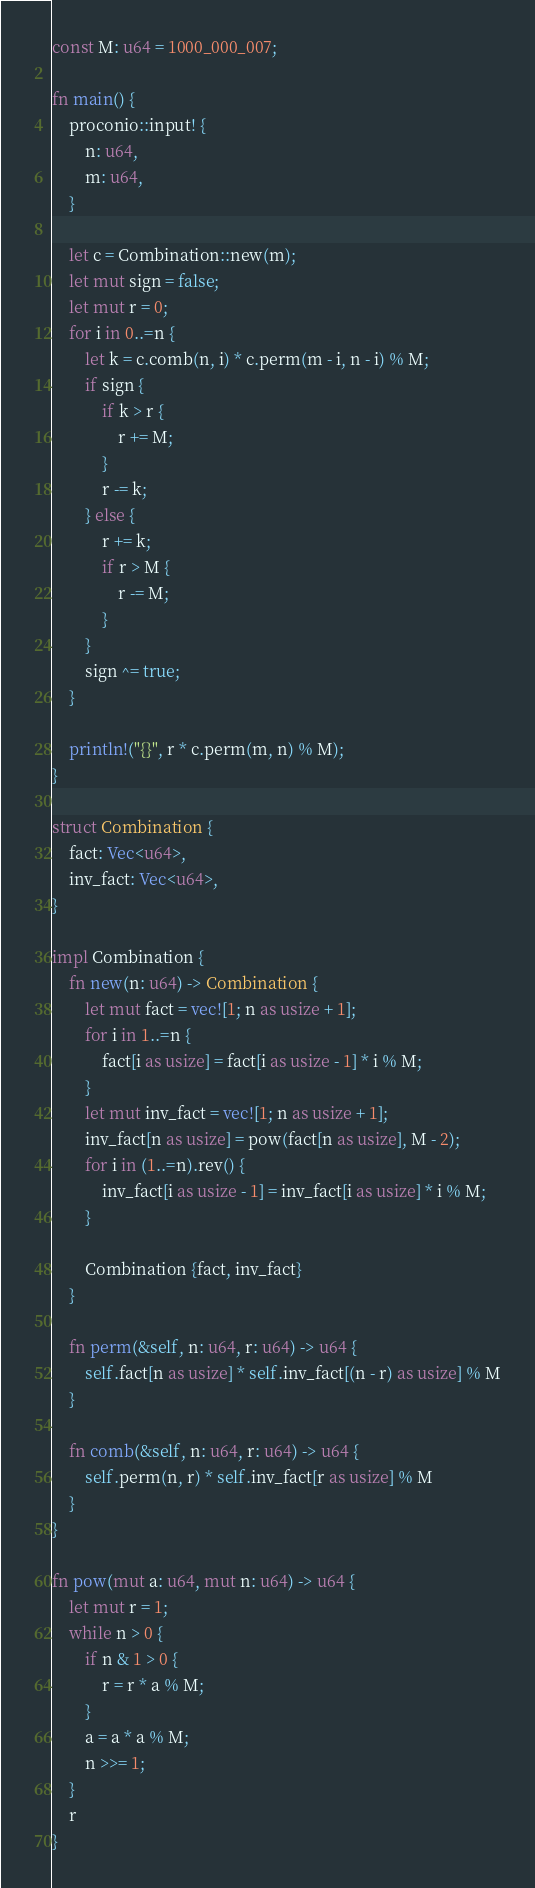<code> <loc_0><loc_0><loc_500><loc_500><_Rust_>const M: u64 = 1000_000_007;

fn main() {
    proconio::input! {
        n: u64,
        m: u64,
    }

    let c = Combination::new(m);
    let mut sign = false;
    let mut r = 0;
    for i in 0..=n {
        let k = c.comb(n, i) * c.perm(m - i, n - i) % M;
        if sign {
            if k > r {
                r += M;
            }
            r -= k;
        } else {
            r += k;
            if r > M {
                r -= M;
            }
        }
        sign ^= true;
    }

    println!("{}", r * c.perm(m, n) % M);
}

struct Combination {
    fact: Vec<u64>,
    inv_fact: Vec<u64>,
}

impl Combination {
    fn new(n: u64) -> Combination {
        let mut fact = vec![1; n as usize + 1];
        for i in 1..=n {
            fact[i as usize] = fact[i as usize - 1] * i % M;
        }
        let mut inv_fact = vec![1; n as usize + 1];
        inv_fact[n as usize] = pow(fact[n as usize], M - 2);
        for i in (1..=n).rev() {
            inv_fact[i as usize - 1] = inv_fact[i as usize] * i % M;
        }

        Combination {fact, inv_fact}
    }

    fn perm(&self, n: u64, r: u64) -> u64 {
        self.fact[n as usize] * self.inv_fact[(n - r) as usize] % M
    }
    
    fn comb(&self, n: u64, r: u64) -> u64 {
        self.perm(n, r) * self.inv_fact[r as usize] % M
    }
}

fn pow(mut a: u64, mut n: u64) -> u64 {
    let mut r = 1;
    while n > 0 {
        if n & 1 > 0 {
            r = r * a % M;
        }
        a = a * a % M;
        n >>= 1;
    }
    r
}
</code> 